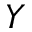Convert formula to latex. <formula><loc_0><loc_0><loc_500><loc_500>Y</formula> 